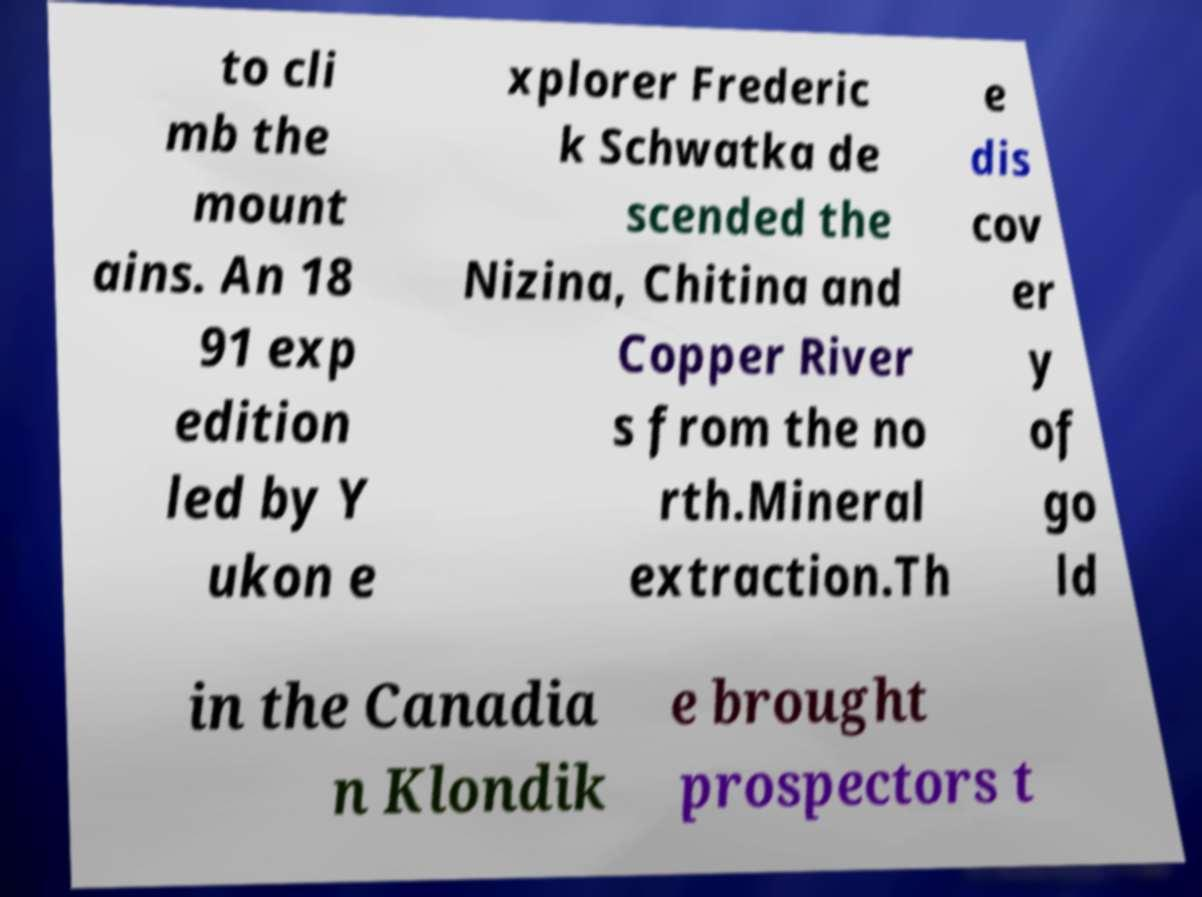For documentation purposes, I need the text within this image transcribed. Could you provide that? to cli mb the mount ains. An 18 91 exp edition led by Y ukon e xplorer Frederic k Schwatka de scended the Nizina, Chitina and Copper River s from the no rth.Mineral extraction.Th e dis cov er y of go ld in the Canadia n Klondik e brought prospectors t 